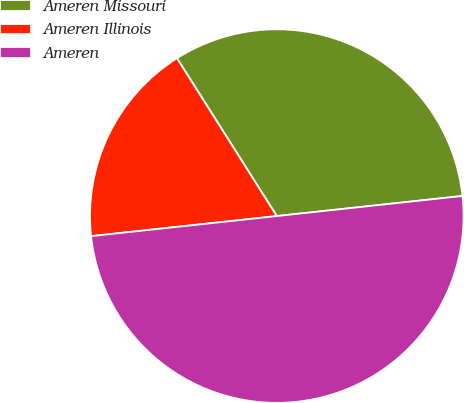<chart> <loc_0><loc_0><loc_500><loc_500><pie_chart><fcel>Ameren Missouri<fcel>Ameren Illinois<fcel>Ameren<nl><fcel>32.26%<fcel>17.74%<fcel>50.0%<nl></chart> 